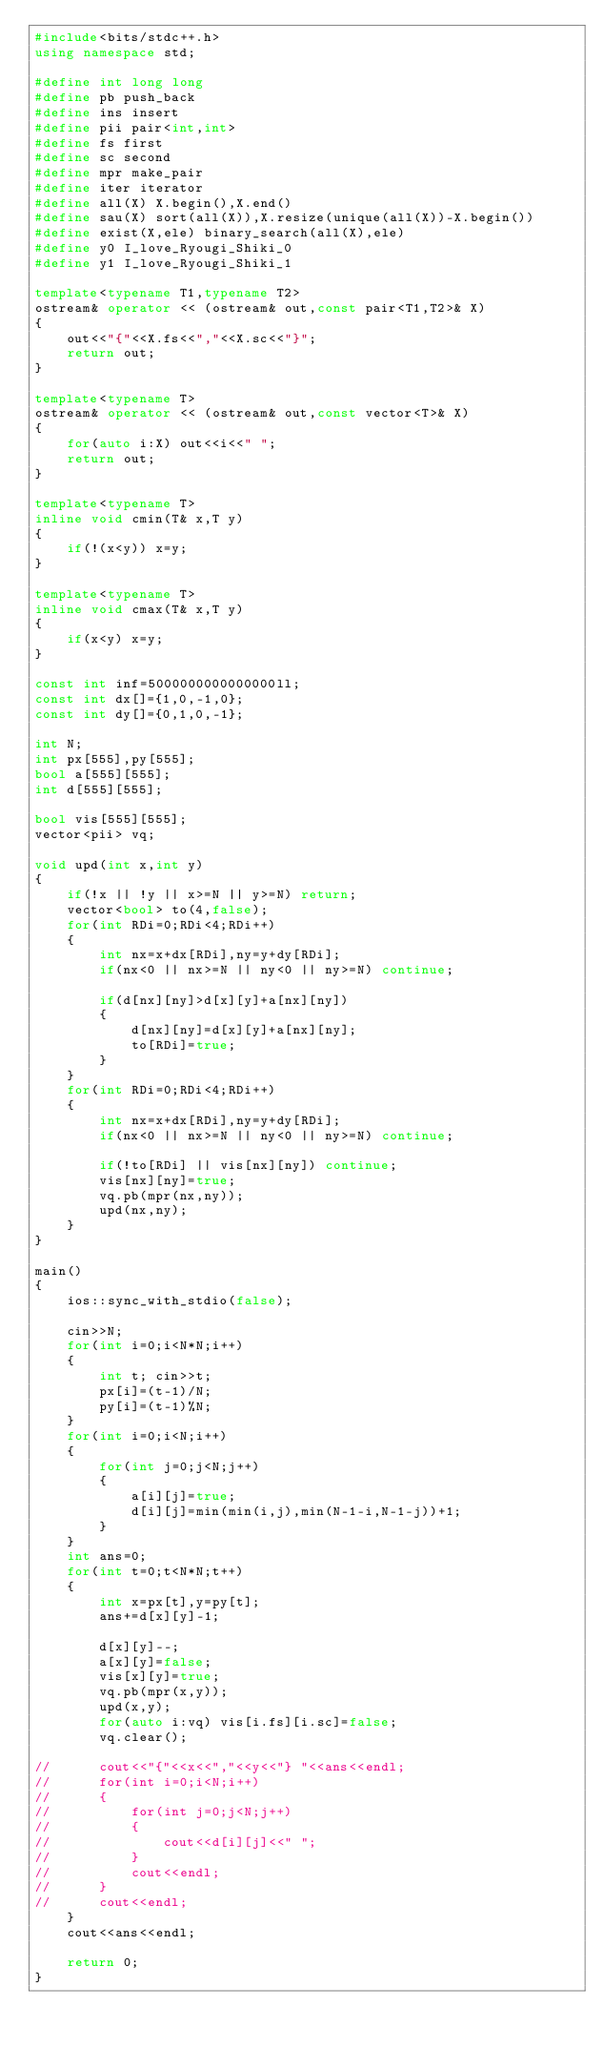Convert code to text. <code><loc_0><loc_0><loc_500><loc_500><_C++_>#include<bits/stdc++.h>
using namespace std;

#define int long long
#define pb push_back
#define ins insert
#define pii pair<int,int>
#define fs first
#define sc second
#define mpr make_pair
#define iter iterator
#define all(X) X.begin(),X.end()
#define sau(X) sort(all(X)),X.resize(unique(all(X))-X.begin())
#define exist(X,ele) binary_search(all(X),ele)
#define y0 I_love_Ryougi_Shiki_0
#define y1 I_love_Ryougi_Shiki_1

template<typename T1,typename T2>
ostream& operator << (ostream& out,const pair<T1,T2>& X)
{
	out<<"{"<<X.fs<<","<<X.sc<<"}";
	return out;
}

template<typename T>
ostream& operator << (ostream& out,const vector<T>& X)
{
	for(auto i:X) out<<i<<" ";
	return out;
}

template<typename T>
inline void cmin(T& x,T y)
{
	if(!(x<y)) x=y;
}

template<typename T>
inline void cmax(T& x,T y)
{
	if(x<y) x=y;
}

const int inf=5000000000000000ll;
const int dx[]={1,0,-1,0};
const int dy[]={0,1,0,-1};

int N;
int px[555],py[555];
bool a[555][555];
int d[555][555];

bool vis[555][555];
vector<pii> vq;

void upd(int x,int y)
{
	if(!x || !y || x>=N || y>=N) return;
	vector<bool> to(4,false);
	for(int RDi=0;RDi<4;RDi++)
	{
		int nx=x+dx[RDi],ny=y+dy[RDi];
		if(nx<0 || nx>=N || ny<0 || ny>=N) continue;
		
		if(d[nx][ny]>d[x][y]+a[nx][ny])
		{
			d[nx][ny]=d[x][y]+a[nx][ny];
			to[RDi]=true;
		}
	}
	for(int RDi=0;RDi<4;RDi++)
	{
		int nx=x+dx[RDi],ny=y+dy[RDi];
		if(nx<0 || nx>=N || ny<0 || ny>=N) continue;
		
		if(!to[RDi] || vis[nx][ny]) continue;
		vis[nx][ny]=true;
		vq.pb(mpr(nx,ny));
		upd(nx,ny);
	}
}

main()
{
	ios::sync_with_stdio(false);
	
	cin>>N;
	for(int i=0;i<N*N;i++)
	{
		int t; cin>>t;
		px[i]=(t-1)/N;
		py[i]=(t-1)%N;
	}
	for(int i=0;i<N;i++)
	{
		for(int j=0;j<N;j++)
		{
			a[i][j]=true;
			d[i][j]=min(min(i,j),min(N-1-i,N-1-j))+1;
		}
	}
	int ans=0;
	for(int t=0;t<N*N;t++)
	{
		int x=px[t],y=py[t];
		ans+=d[x][y]-1;
		
		d[x][y]--;
		a[x][y]=false;
		vis[x][y]=true;
		vq.pb(mpr(x,y));
		upd(x,y);
		for(auto i:vq) vis[i.fs][i.sc]=false;
		vq.clear();
		
//		cout<<"{"<<x<<","<<y<<"} "<<ans<<endl;
//		for(int i=0;i<N;i++)
//		{
//			for(int j=0;j<N;j++)
//			{
//				cout<<d[i][j]<<" ";
//			}
//			cout<<endl;
//		}
//		cout<<endl;
	}
	cout<<ans<<endl;
	
	return 0;
}




















</code> 